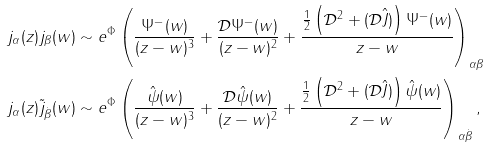Convert formula to latex. <formula><loc_0><loc_0><loc_500><loc_500>& j _ { \alpha } ( z ) j _ { \beta } ( w ) \sim e ^ { \Phi } \left ( \frac { \Psi ^ { - } ( w ) } { ( z - w ) ^ { 3 } } + \frac { \mathcal { D } \Psi ^ { - } ( w ) } { ( z - w ) ^ { 2 } } + \frac { \frac { 1 } { 2 } \left ( \mathcal { D } ^ { 2 } + ( \mathcal { D } \hat { J } ) \right ) \Psi ^ { - } ( w ) } { z - w } \right ) _ { \alpha \beta } \\ & j _ { \alpha } ( z ) \tilde { j } _ { \dot { \beta } } ( w ) \sim e ^ { \Phi } \left ( \frac { \hat { \psi } ( w ) } { ( z - w ) ^ { 3 } } + \frac { \mathcal { D } \hat { \psi } ( w ) } { ( z - w ) ^ { 2 } } + \frac { \frac { 1 } { 2 } \left ( \mathcal { D } ^ { 2 } + ( \mathcal { D } \hat { J } ) \right ) \hat { \psi } ( w ) } { z - w } \right ) _ { \alpha \dot { \beta } } ,</formula> 